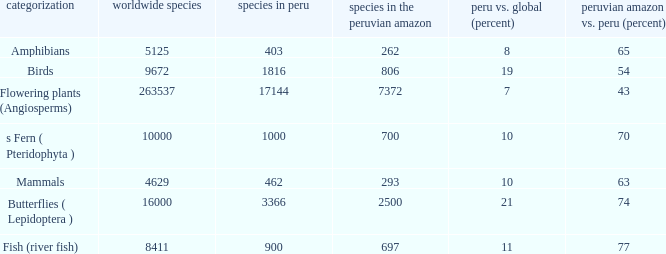What's the species in the world with peruvian amazon vs. peru (percent)  of 63 4629.0. 